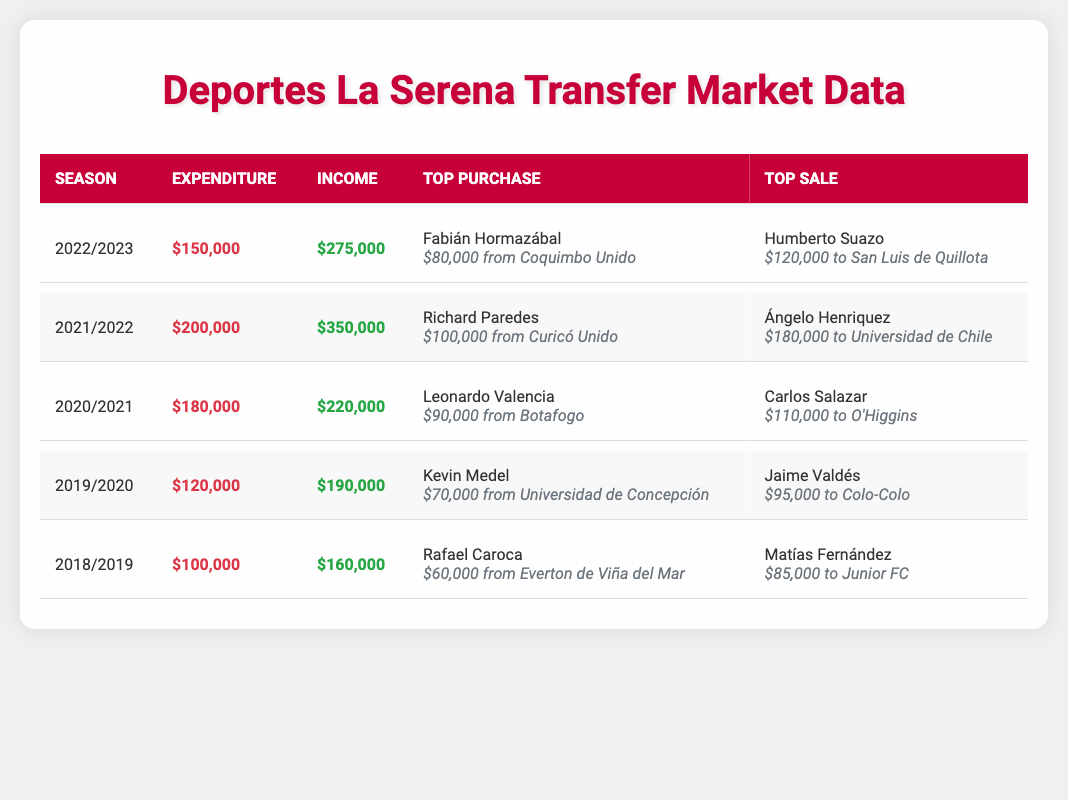What was the highest income for Deportes La Serena in a single season? In the table, we see the income values for each season: $275,000 for 2022/2023, $350,000 for 2021/2022, $220,000 for 2020/2021, $190,000 for 2019/2020, and $160,000 for 2018/2019. The highest value among these is $350,000 for the 2021/2022 season.
Answer: $350,000 How much did Deportes La Serena spend in total over the five seasons? The total expenditure can be calculated by adding the expenditure for each season: $150,000 + $200,000 + $180,000 + $120,000 + $100,000 = $750,000.
Answer: $750,000 Did Deportes La Serena have more income than expenditure in all five seasons? By comparing expenditure and income for each season, we see that in 2022/2023 ($150,000 vs. $275,000), 2021/2022 ($200,000 vs. $350,000), 2020/2021 ($180,000 vs. $220,000), 2019/2020 ($120,000 vs. $190,000), and 2018/2019 ($100,000 vs. $160,000), they had more income than expenditure in all seasons.
Answer: Yes What was the average expenditure over the five seasons? To calculate the average, we first find the total expenditure, which is $750,000, and then divide this by the number of seasons, which is 5: $750,000 / 5 = $150,000.
Answer: $150,000 Which season did Deportes La Serena have the highest transfer expenditure, and what was the amount? The expenditure amounts are $150,000 for 2022/2023, $200,000 for 2021/2022, $180,000 for 2020/2021, $120,000 for 2019/2020, and $100,000 for 2018/2019. The highest value is $200,000, occurring in the 2021/2022 season.
Answer: 2021/2022, $200,000 Did the top sale in the 2022/2023 season exceed $100,000? The top sale for 2022/2023 was Humberto Suazo for $120,000. Since $120,000 is greater than $100,000, the answer is affirmative.
Answer: Yes How many players were acquired for less than $80,000 in the last five seasons? The top purchases show Fabián Hormazábal for $80,000, Richard Paredes for $100,000, Leonardo Valencia for $90,000, Kevin Medel for $70,000, and Rafael Caroca for $60,000. Only Kevin Medel and Rafael Caroca were acquired for less than $80,000 (totaling 2 players).
Answer: 2 players What was the net income for Deportes La Serena in the season 2021/2022? To find the net income, subtract the expenditure from the income for the season: $350,000 - $200,000 = $150,000 for 2021/2022.
Answer: $150,000 Which player brought in the highest fee for Deportes La Serena, and what was that fee? The top sale amounts in each season show that Ángelo Henriquez sold for $180,000 in the 2021/2022 season, which is greater than any other sale value in the other seasons: $120,000, $110,000, $95,000, and $85,000. Thus, the highest fee came from the 2021/2022 season.
Answer: Ángelo Henriquez, $180,000 